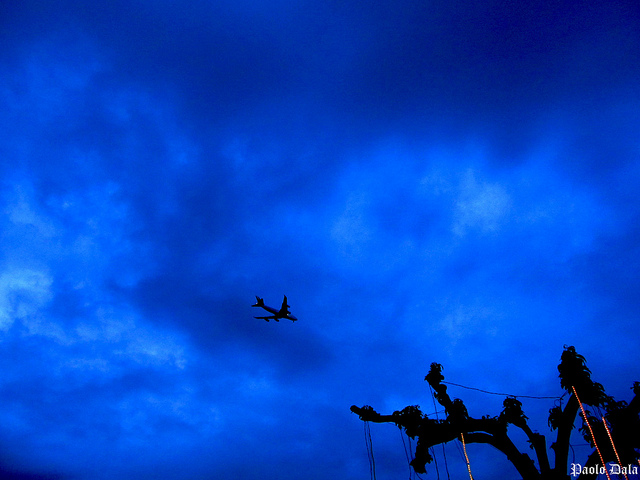Please transcribe the text in this image. paolo Dala 